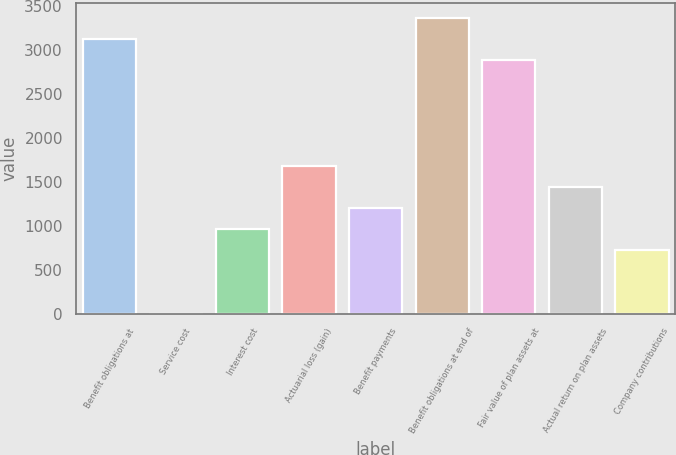<chart> <loc_0><loc_0><loc_500><loc_500><bar_chart><fcel>Benefit obligations at<fcel>Service cost<fcel>Interest cost<fcel>Actuarial loss (gain)<fcel>Benefit payments<fcel>Benefit obligations at end of<fcel>Fair value of plan assets at<fcel>Actual return on plan assets<fcel>Company contributions<nl><fcel>3127.5<fcel>1<fcel>963<fcel>1684.5<fcel>1203.5<fcel>3368<fcel>2887<fcel>1444<fcel>722.5<nl></chart> 